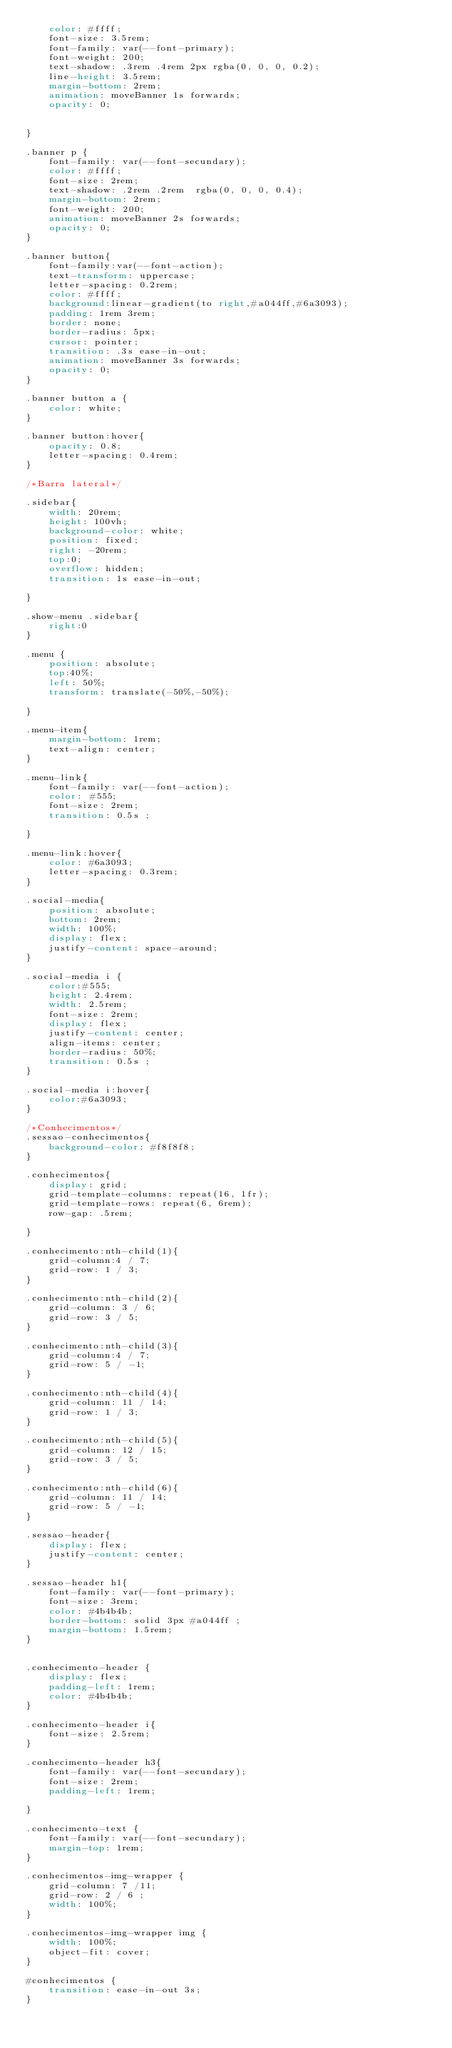<code> <loc_0><loc_0><loc_500><loc_500><_CSS_>    color: #ffff;
    font-size: 3.5rem;
    font-family: var(--font-primary);
    font-weight: 200;
    text-shadow: .3rem .4rem 2px rgba(0, 0, 0, 0.2);
    line-height: 3.5rem;
    margin-bottom: 2rem;
    animation: moveBanner 1s forwards;
    opacity: 0;

    
}

.banner p {
    font-family: var(--font-secundary);
    color: #ffff;
    font-size: 2rem;
    text-shadow: .2rem .2rem  rgba(0, 0, 0, 0.4);
    margin-bottom: 2rem;
    font-weight: 200;
    animation: moveBanner 2s forwards;
    opacity: 0;
}

.banner button{
    font-family:var(--font-action);
    text-transform: uppercase;
    letter-spacing: 0.2rem;
    color: #ffff;
    background:linear-gradient(to right,#a044ff,#6a3093);
    padding: 1rem 3rem;
    border: none;
    border-radius: 5px;
    cursor: pointer;
    transition: .3s ease-in-out;
    animation: moveBanner 3s forwards;
    opacity: 0;
}

.banner button a {
    color: white;
}

.banner button:hover{
    opacity: 0.8;
    letter-spacing: 0.4rem;
}

/*Barra lateral*/

.sidebar{
    width: 20rem;
    height: 100vh;
    background-color: white;
    position: fixed;
    right: -20rem;
    top:0;
    overflow: hidden;
    transition: 1s ease-in-out;

}

.show-menu .sidebar{
    right:0
}

.menu {
    position: absolute;
    top:40%;
    left: 50%;
    transform: translate(-50%,-50%);
    
}

.menu-item{
    margin-bottom: 1rem; 
    text-align: center;
}

.menu-link{
    font-family: var(--font-action);
    color: #555;
    font-size: 2rem;
    transition: 0.5s ;

}

.menu-link:hover{
    color: #6a3093;
    letter-spacing: 0.3rem;
}

.social-media{
    position: absolute;
    bottom: 2rem;
    width: 100%;
    display: flex;
    justify-content: space-around;
}

.social-media i {
    color:#555;
    height: 2.4rem;
    width: 2.5rem;
    font-size: 2rem;
    display: flex;
    justify-content: center;
    align-items: center;
    border-radius: 50%;
    transition: 0.5s ;
}

.social-media i:hover{
    color:#6a3093;
} 

/*Conhecimentos*/
.sessao-conhecimentos{
    background-color: #f8f8f8;
}

.conhecimentos{
    display: grid;
    grid-template-columns: repeat(16, 1fr);
    grid-template-rows: repeat(6, 6rem);
    row-gap: .5rem;

}

.conhecimento:nth-child(1){
    grid-column:4 / 7;
    grid-row: 1 / 3;
}

.conhecimento:nth-child(2){
    grid-column: 3 / 6;
    grid-row: 3 / 5;
}

.conhecimento:nth-child(3){
    grid-column:4 / 7;
    grid-row: 5 / -1;
}

.conhecimento:nth-child(4){
    grid-column: 11 / 14;
    grid-row: 1 / 3;
}

.conhecimento:nth-child(5){
    grid-column: 12 / 15;
    grid-row: 3 / 5;
}

.conhecimento:nth-child(6){
    grid-column: 11 / 14;
    grid-row: 5 / -1;
}

.sessao-header{
    display: flex;
    justify-content: center;
}

.sessao-header h1{
    font-family: var(--font-primary);
    font-size: 3rem;
    color: #4b4b4b;
    border-bottom: solid 3px #a044ff ;
    margin-bottom: 1.5rem;
}


.conhecimento-header {
    display: flex;
    padding-left: 1rem;
    color: #4b4b4b;
}

.conhecimento-header i{
    font-size: 2.5rem;
}

.conhecimento-header h3{
    font-family: var(--font-secundary);
    font-size: 2rem;
    padding-left: 1rem;

}

.conhecimento-text {
    font-family: var(--font-secundary);
    margin-top: 1rem;
}

.conhecimentos-img-wrapper {
    grid-column: 7 /11;
    grid-row: 2 / 6 ;
    width: 100%;
}

.conhecimentos-img-wrapper img {
    width: 100%;
    object-fit: cover;
}

#conhecimentos {
    transition: ease-in-out 3s;
}























</code> 